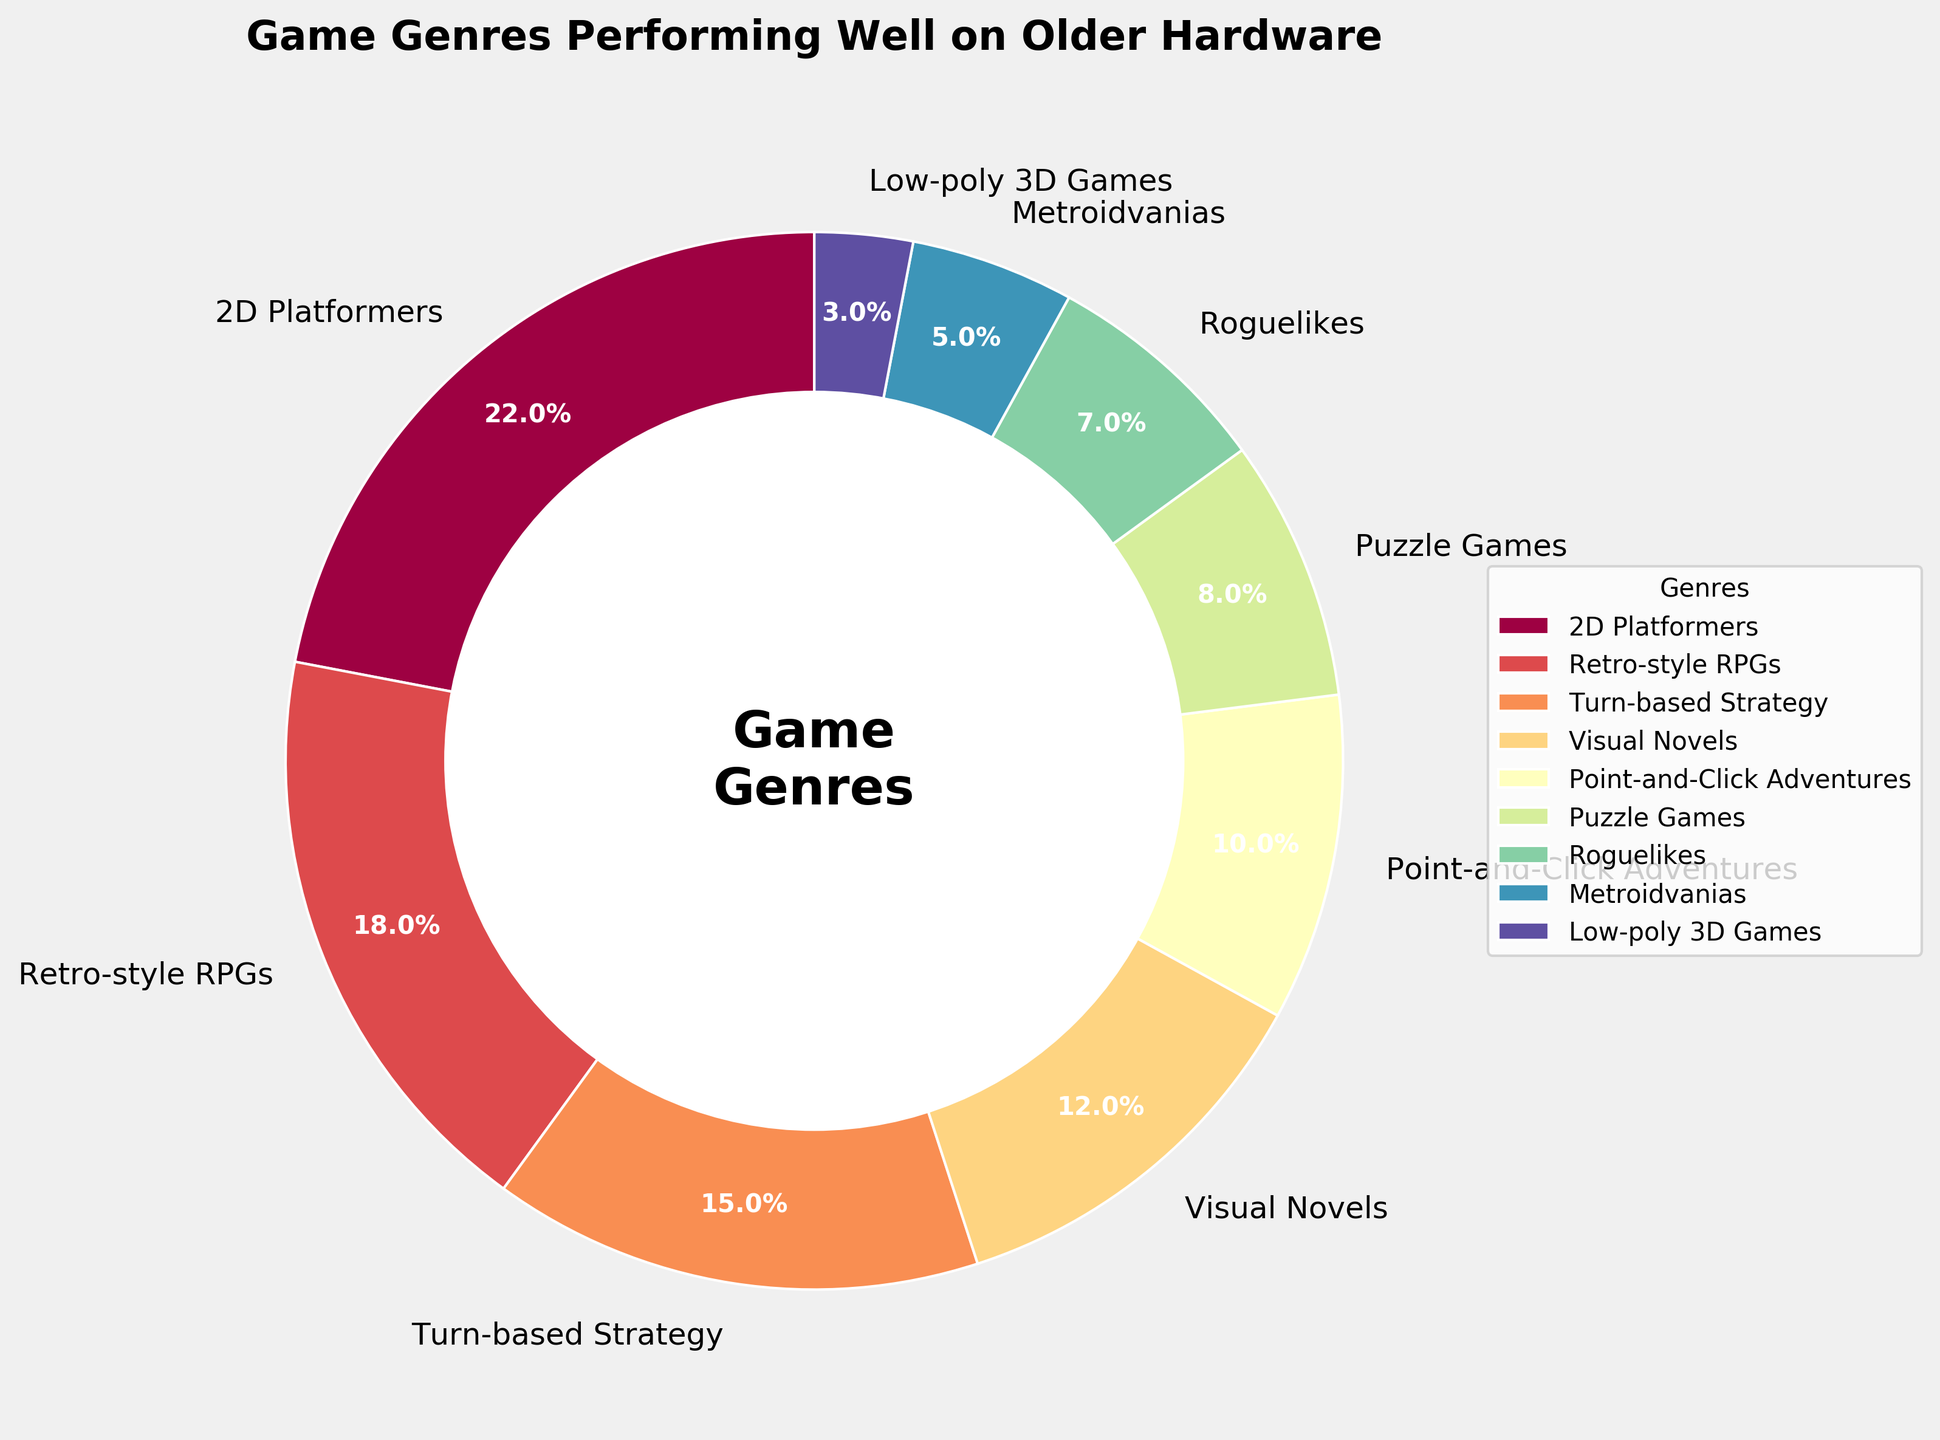Which genre has the highest percentage of games that perform well on older hardware? To find the genre with the highest percentage, look for the largest wedge in the pie chart. The labeling on the chart shows the percentage values next to each genre.
Answer: 2D Platformers What is the total percentage of games that fall into the top three genres? Identify the top three percentages from the pie chart: 22% for 2D Platformers, 18% for Retro-style RPGs, and 15% for Turn-based Strategy. Sum these percentages: 22 + 18 + 15 = 55%.
Answer: 55% Which genre has a smaller percentage, Roguelikes or Metroidvanias? Compare the wedges labeled as Roguelikes (7%) and Metroidvanias (5%). The wedge of Metroidvanias is visually smaller than that of Roguelikes.
Answer: Metroidvanias What is the percentage difference between Visual Novels and Point-and-Click Adventures? Find the percentages for Visual Novels (12%) and Point-and-Click Adventures (10%). Subtract 10 from 12 to get the difference: 12 - 10 = 2%.
Answer: 2% What percentage of games do Puzzle Games and Low-poly 3D Games represent together? Identify the individual percentages for Puzzle Games (8%) and Low-poly 3D Games (3%). Sum these percentages: 8 + 3 = 11%.
Answer: 11% Which genre comes right after Point-and-Click Adventures in terms of performance percentage? Look at the percentages to locate Point-and-Click Adventures (10%). The next higher percentage is Visual Novels (12%).
Answer: Visual Novels What is the average percentage of the bottom three genres? The bottom three genres by percentage are Metroidvanias (5%), Low-poly 3D Games (3%), and Roguelikes (7%). Calculate their sum and divide by 3: (5 + 3 + 7)/3 = 5%.
Answer: 5% Between Retro-style RPGs and Turn-based Strategy, which genre has a higher percentage and by how much? Compare Retro-style RPGs (18%) and Turn-based Strategy (15%). Subtract the smaller percentage from the larger one: 18 - 15 = 3%.
Answer: Retro-style RPGs, 3% Looking at the color-coded wedges, which genre has the lightest color? Identify the wedges and their colors. The lightest color corresponds to the section with the smallest percentage. According to the given data, Low-poly 3D Games (3%) has the smallest percentage, and thus, the lightest color.
Answer: Low-poly 3D Games 